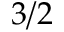Convert formula to latex. <formula><loc_0><loc_0><loc_500><loc_500>3 / 2</formula> 